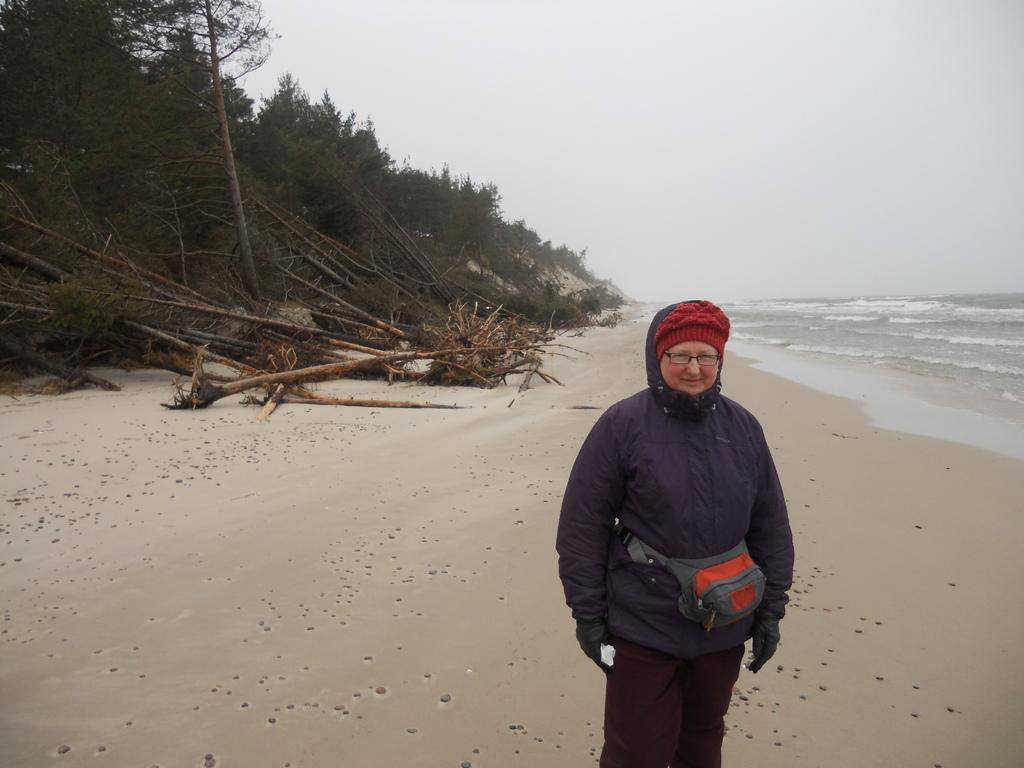What is the main subject of the image? There is a person standing in the image. Where is the person standing? The person is standing on a path. What can be seen in the background of the image? There are trees, a sea, and the sky visible in the background of the image. What type of shoes is the person wearing in the image? The provided facts do not mention any shoes, so we cannot determine the type of shoes the person is wearing. 